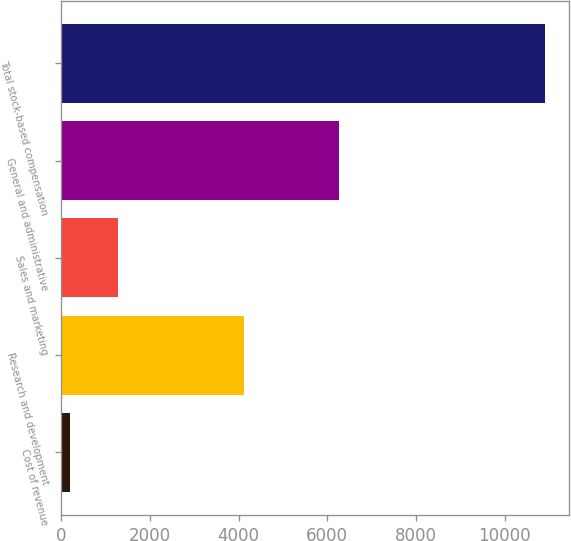Convert chart. <chart><loc_0><loc_0><loc_500><loc_500><bar_chart><fcel>Cost of revenue<fcel>Research and development<fcel>Sales and marketing<fcel>General and administrative<fcel>Total stock-based compensation<nl><fcel>200<fcel>4126<fcel>1270<fcel>6261<fcel>10900<nl></chart> 